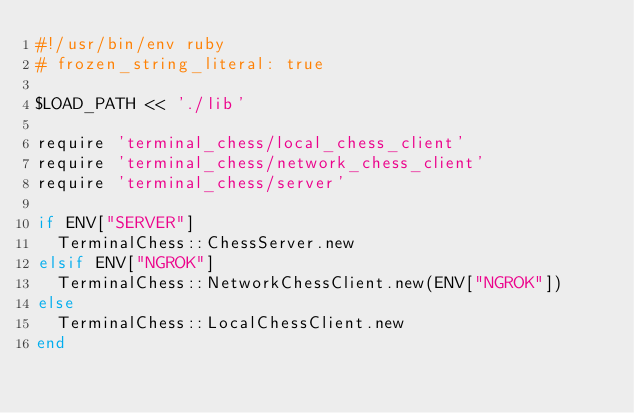<code> <loc_0><loc_0><loc_500><loc_500><_Ruby_>#!/usr/bin/env ruby
# frozen_string_literal: true

$LOAD_PATH << './lib'

require 'terminal_chess/local_chess_client'
require 'terminal_chess/network_chess_client'
require 'terminal_chess/server'

if ENV["SERVER"]
  TerminalChess::ChessServer.new
elsif ENV["NGROK"]
  TerminalChess::NetworkChessClient.new(ENV["NGROK"])
else
  TerminalChess::LocalChessClient.new
end
</code> 